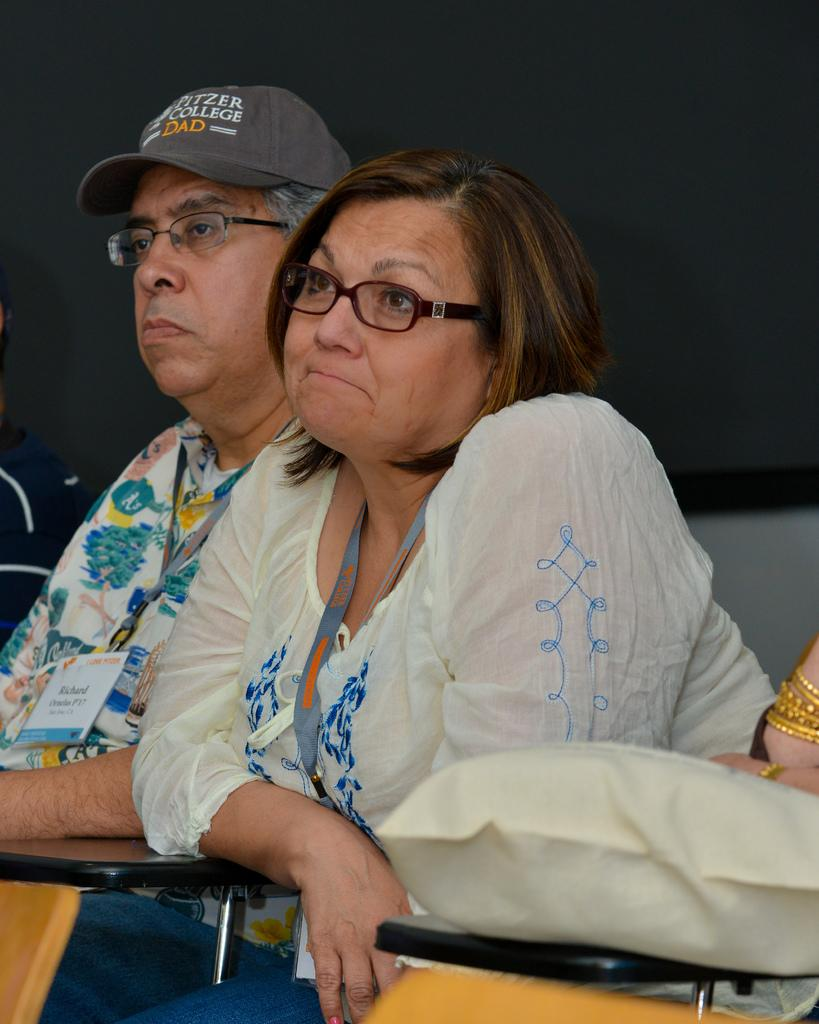How many people are present in the image? There are two people, a man and a woman, present in the image. What are the man and the woman wearing on their faces? Both the man and the woman are wearing glasses (specs) in the image. What else are the man and the woman wearing? Both the man and the woman are wearing tags in the image. What is the man wearing on his head? The man is wearing a cap in the image. What can be seen near the man and the woman? There are stands near the man and the woman in the image. What is visible in the background of the image? There is a wall in the background of the image. What type of lead can be seen in the man's pocket in the image? There is no lead visible in the image, nor is there any indication that the man has a pocket. 